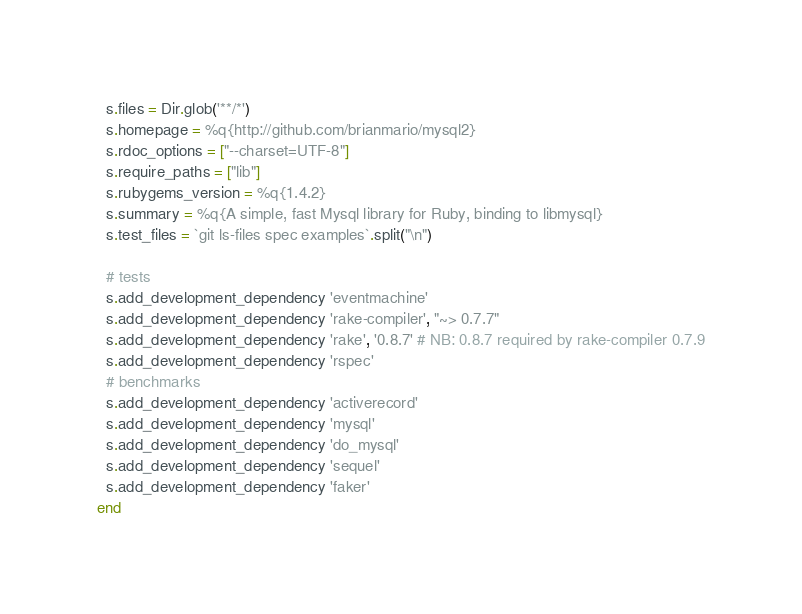Convert code to text. <code><loc_0><loc_0><loc_500><loc_500><_Ruby_>  s.files = Dir.glob('**/*')
  s.homepage = %q{http://github.com/brianmario/mysql2}
  s.rdoc_options = ["--charset=UTF-8"]
  s.require_paths = ["lib"]
  s.rubygems_version = %q{1.4.2}
  s.summary = %q{A simple, fast Mysql library for Ruby, binding to libmysql}
  s.test_files = `git ls-files spec examples`.split("\n")

  # tests
  s.add_development_dependency 'eventmachine'
  s.add_development_dependency 'rake-compiler', "~> 0.7.7"
  s.add_development_dependency 'rake', '0.8.7' # NB: 0.8.7 required by rake-compiler 0.7.9
  s.add_development_dependency 'rspec'
  # benchmarks
  s.add_development_dependency 'activerecord'
  s.add_development_dependency 'mysql'
  s.add_development_dependency 'do_mysql'
  s.add_development_dependency 'sequel'
  s.add_development_dependency 'faker'
end
</code> 